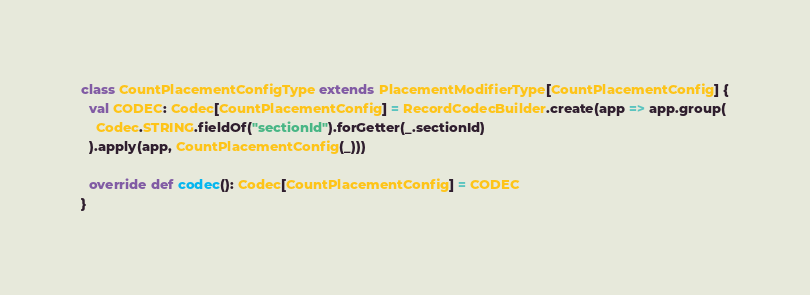<code> <loc_0><loc_0><loc_500><loc_500><_Scala_>
class CountPlacementConfigType extends PlacementModifierType[CountPlacementConfig] {
  val CODEC: Codec[CountPlacementConfig] = RecordCodecBuilder.create(app => app.group(
    Codec.STRING.fieldOf("sectionId").forGetter(_.sectionId)
  ).apply(app, CountPlacementConfig(_)))

  override def codec(): Codec[CountPlacementConfig] = CODEC
}</code> 